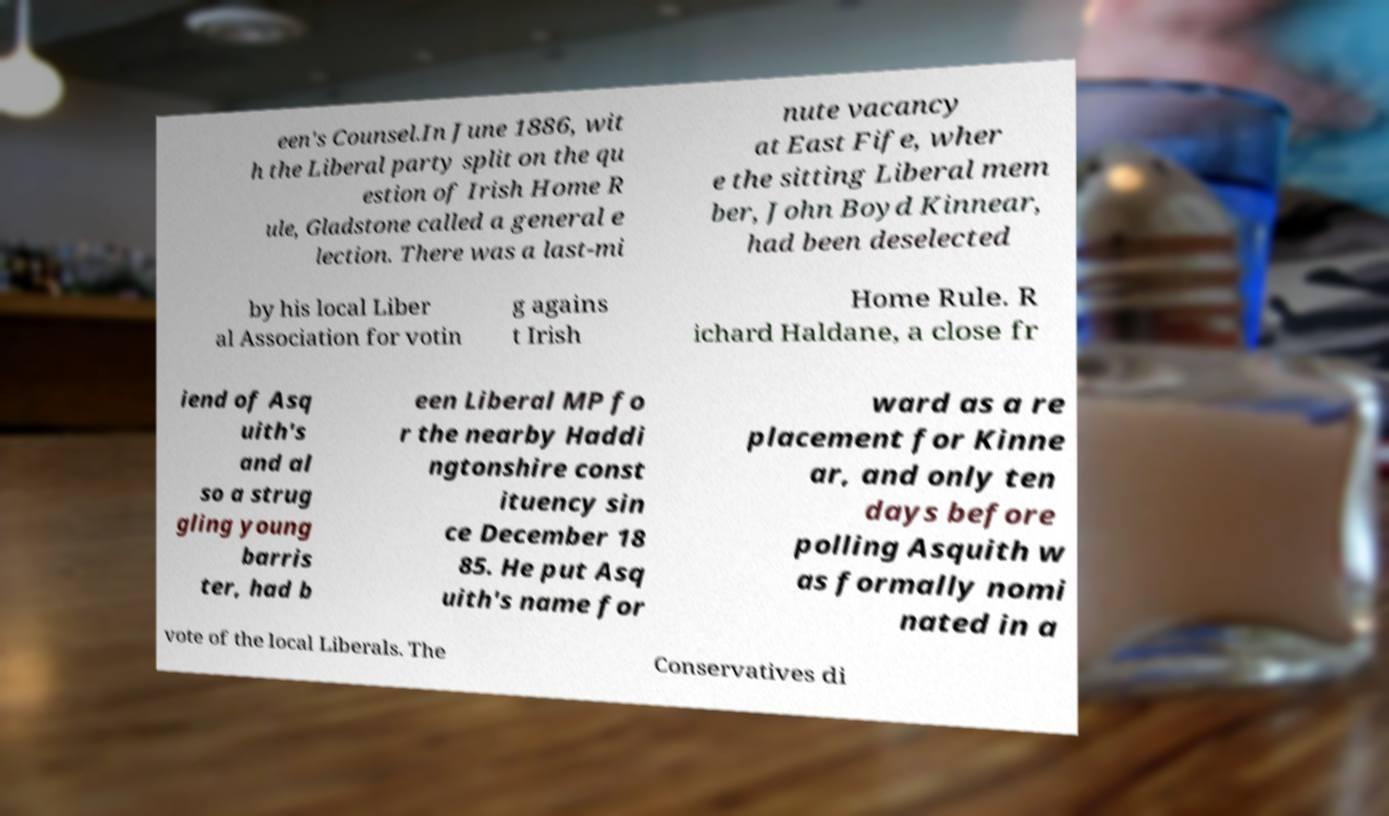Please identify and transcribe the text found in this image. een's Counsel.In June 1886, wit h the Liberal party split on the qu estion of Irish Home R ule, Gladstone called a general e lection. There was a last-mi nute vacancy at East Fife, wher e the sitting Liberal mem ber, John Boyd Kinnear, had been deselected by his local Liber al Association for votin g agains t Irish Home Rule. R ichard Haldane, a close fr iend of Asq uith's and al so a strug gling young barris ter, had b een Liberal MP fo r the nearby Haddi ngtonshire const ituency sin ce December 18 85. He put Asq uith's name for ward as a re placement for Kinne ar, and only ten days before polling Asquith w as formally nomi nated in a vote of the local Liberals. The Conservatives di 